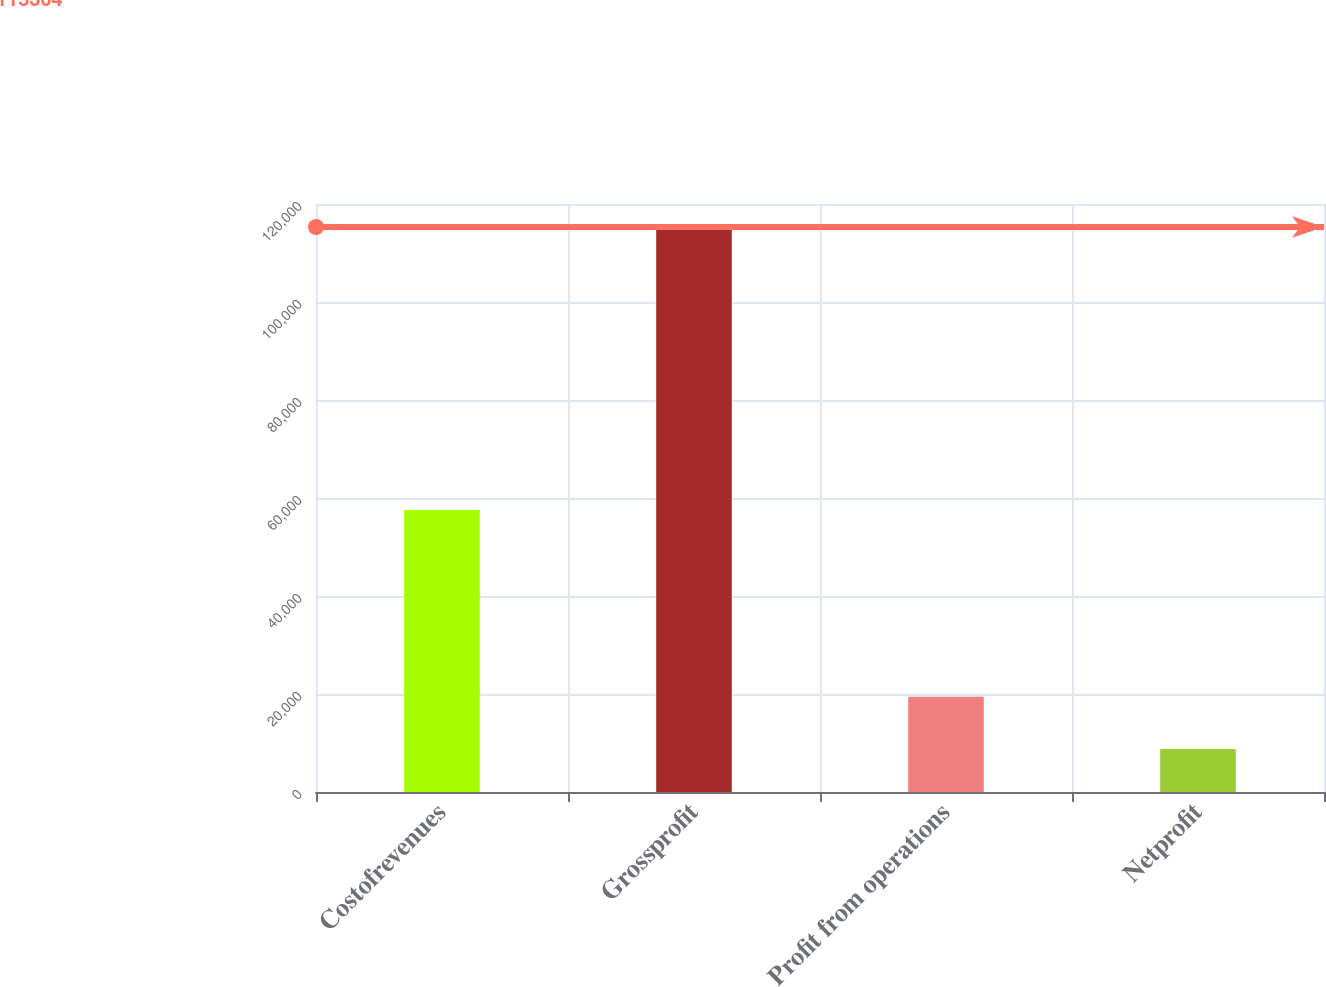Convert chart. <chart><loc_0><loc_0><loc_500><loc_500><bar_chart><fcel>Costofrevenues<fcel>Grossprofit<fcel>Profit from operations<fcel>Netprofit<nl><fcel>57526<fcel>115304<fcel>19421.6<fcel>8768<nl></chart> 